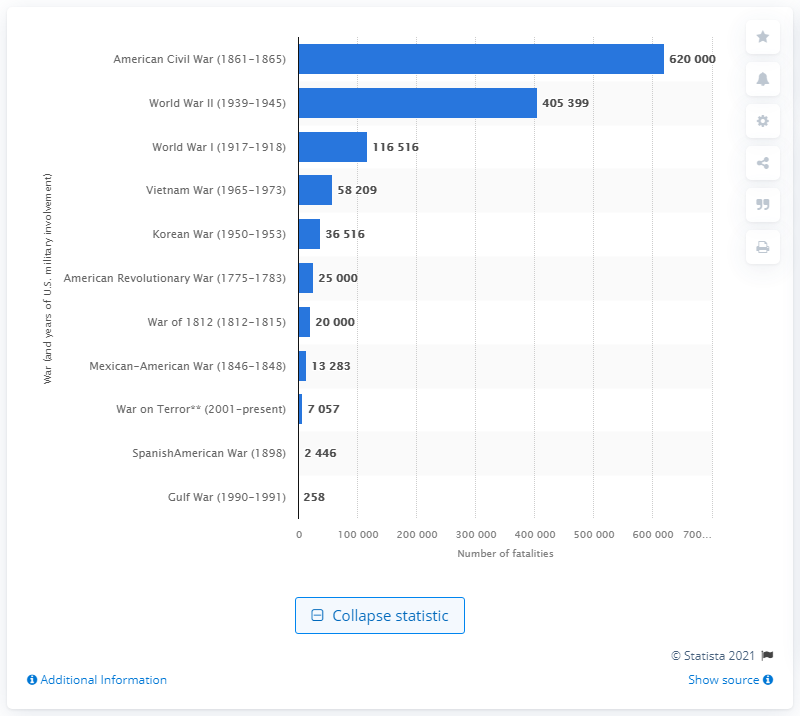Outline some significant characteristics in this image. The American Civil War resulted in the deaths of approximately 620,000 people. 